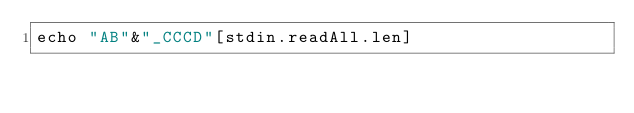Convert code to text. <code><loc_0><loc_0><loc_500><loc_500><_Nim_>echo "AB"&"_CCCD"[stdin.readAll.len]</code> 